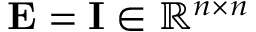Convert formula to latex. <formula><loc_0><loc_0><loc_500><loc_500>E = I \in \mathbb { R } ^ { n \times n }</formula> 